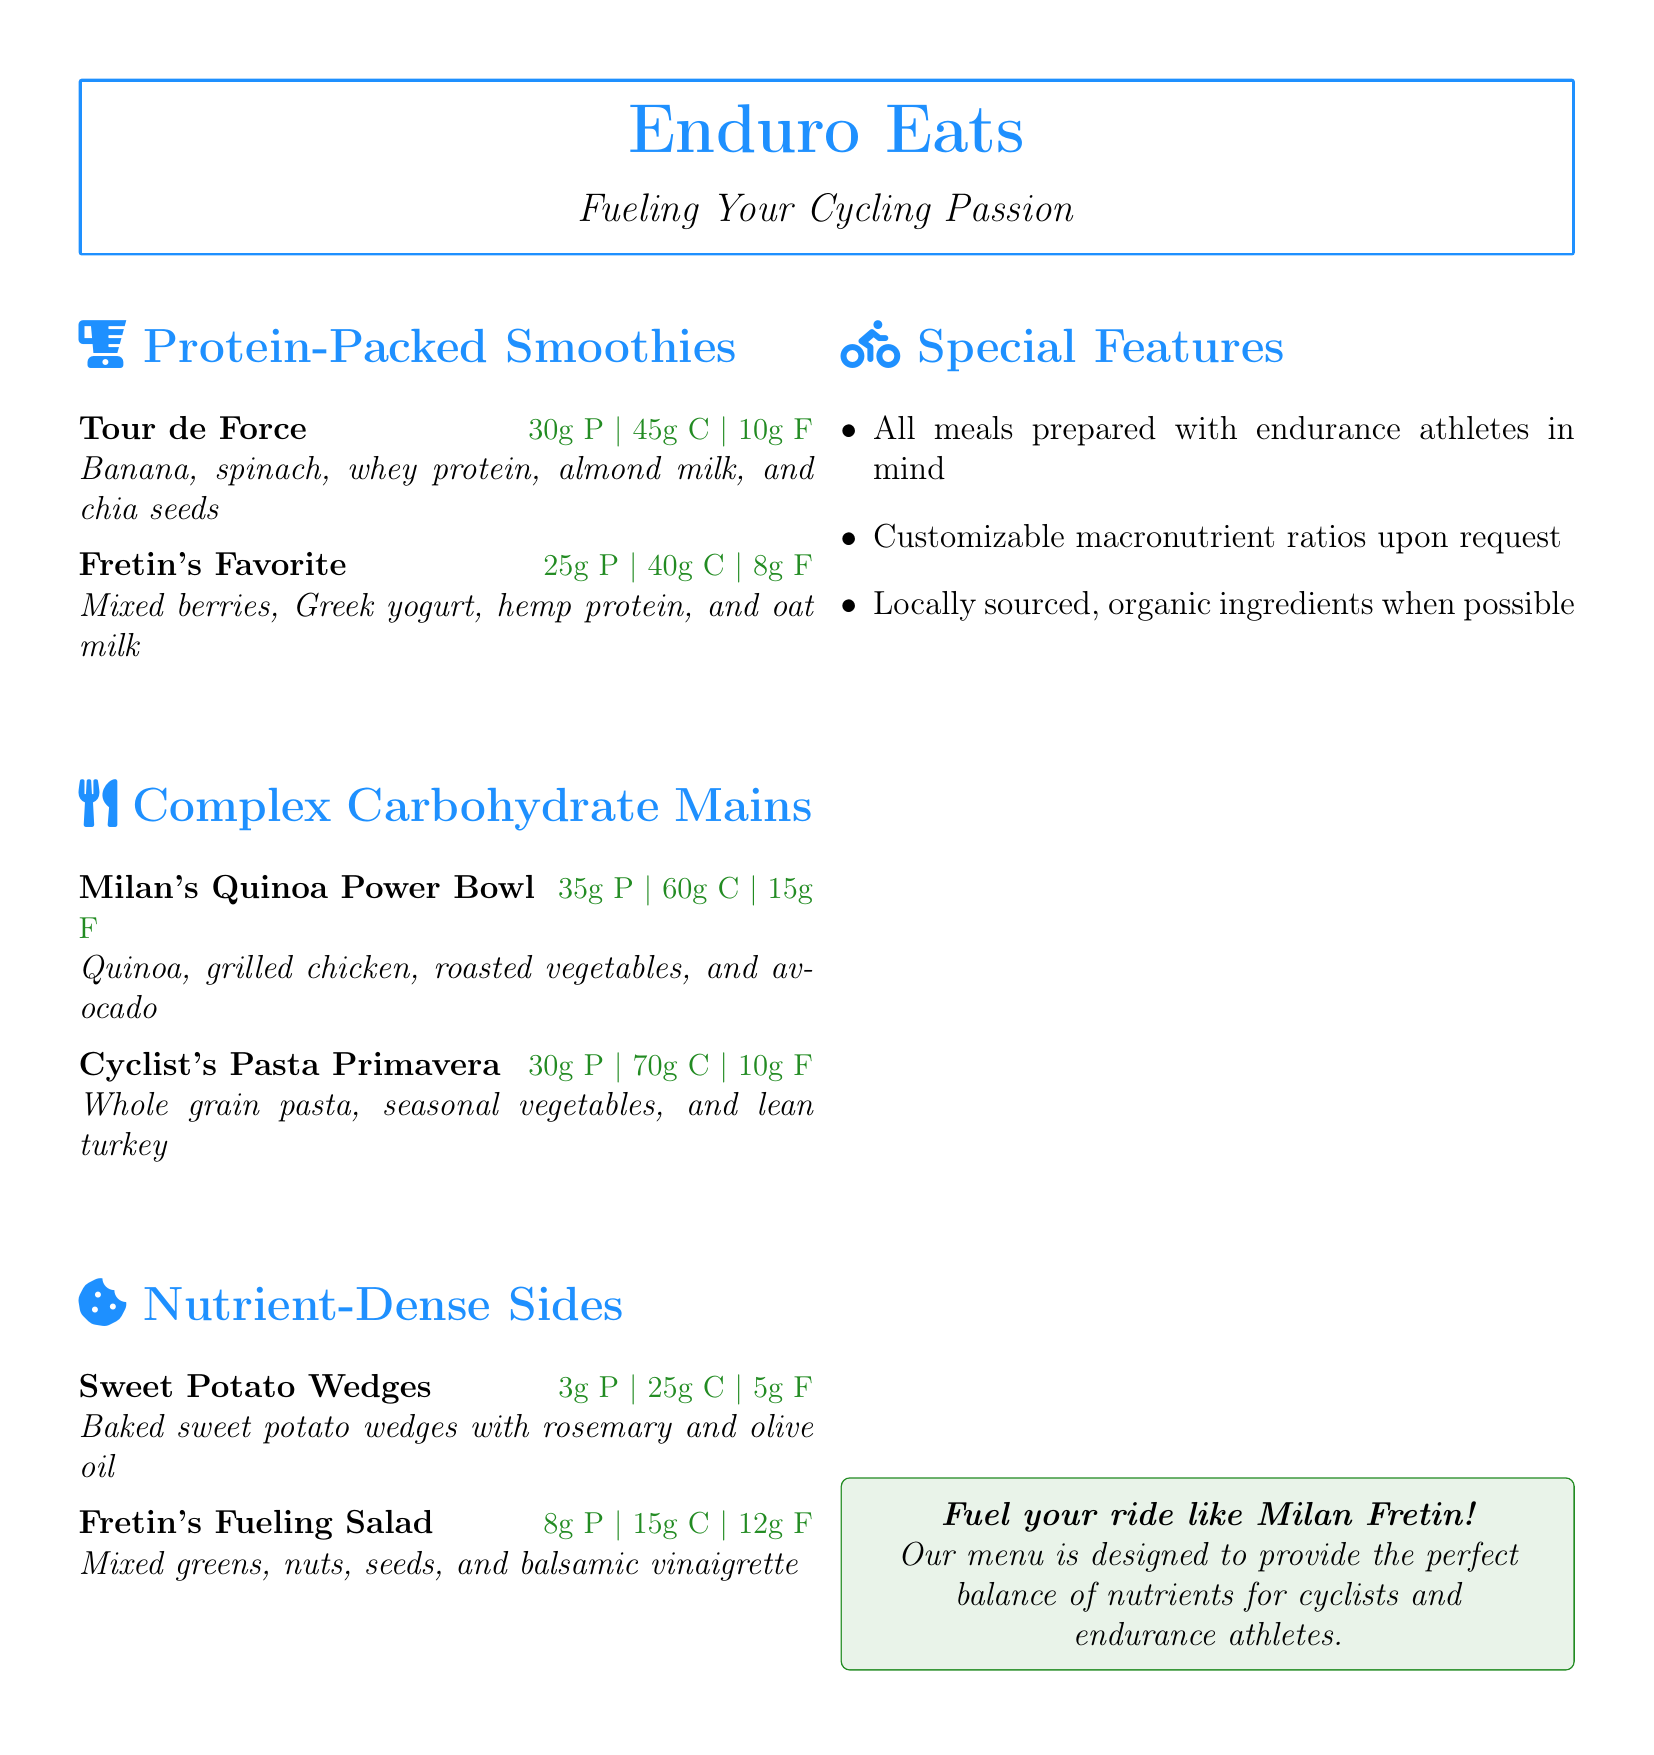what is the name of the protein-packed smoothie with mixed berries? The name of the smoothie is provided in the menu item under Protein-Packed Smoothies, which includes Mixed berries, Greek yogurt, hemp protein, and oat milk.
Answer: Fretin's Favorite how many grams of protein are in Milan's Quinoa Power Bowl? The protein content for Milan's Quinoa Power Bowl is listed in the menu information.
Answer: 35g P what type of carbohydrate option is the Cyclist's Pasta Primavera? This is a complex carbohydrate main dish, as indicated in the menu section.
Answer: Complex Carbohydrate Mains what are the primary ingredients in the Tour de Force smoothie? The ingredients are listed with the menu item details, which provides a breakdown of its composition.
Answer: Banana, spinach, whey protein, almond milk, and chia seeds how many grams of fat does Fretin's Fueling Salad contain? The fat content is specified alongside its ingredient details in the menu item entry for Fretin's Fueling Salad.
Answer: 12g F what feature is unique to this health-focused restaurant menu? The menu emphasizes a unique aspect that it is designed with a specific clientele in mind, mainly endurance athletes.
Answer: All meals prepared with endurance athletes in mind can meals be customized for macronutrient ratios? The menu has a point listing this specific capability for customers looking for tailored options.
Answer: Yes how many grams of carbohydrates are provided by the Cyclist's Pasta Primavera? The carbohydrate content is provided in the menu item description under Complex Carbohydrate Mains.
Answer: 70g C 